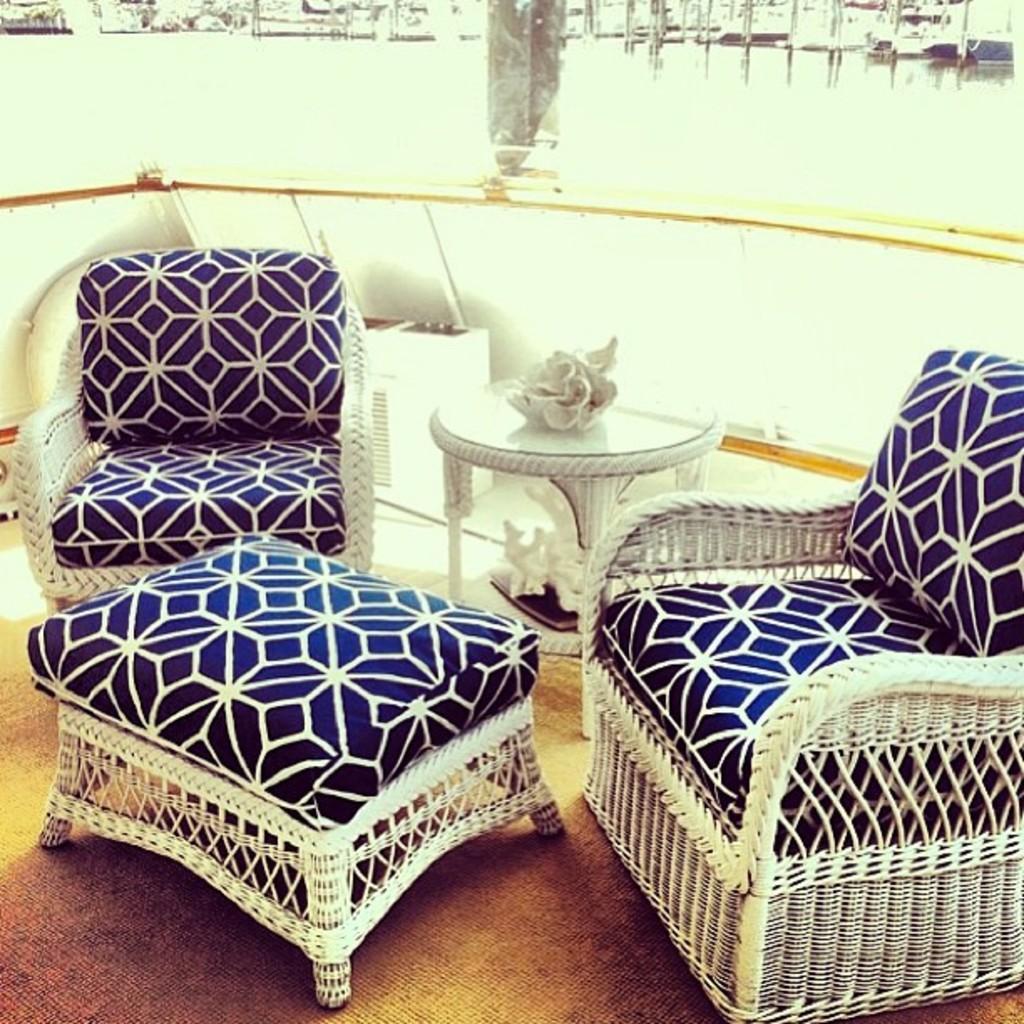In one or two sentences, can you explain what this image depicts? In this picture we can see chairs, tables on the floor and some objects. 